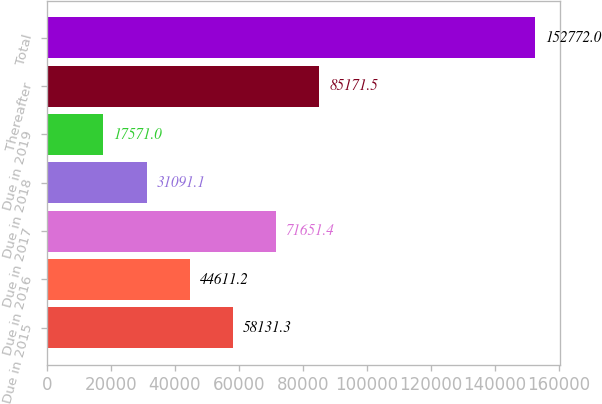<chart> <loc_0><loc_0><loc_500><loc_500><bar_chart><fcel>Due in 2015<fcel>Due in 2016<fcel>Due in 2017<fcel>Due in 2018<fcel>Due in 2019<fcel>Thereafter<fcel>Total<nl><fcel>58131.3<fcel>44611.2<fcel>71651.4<fcel>31091.1<fcel>17571<fcel>85171.5<fcel>152772<nl></chart> 